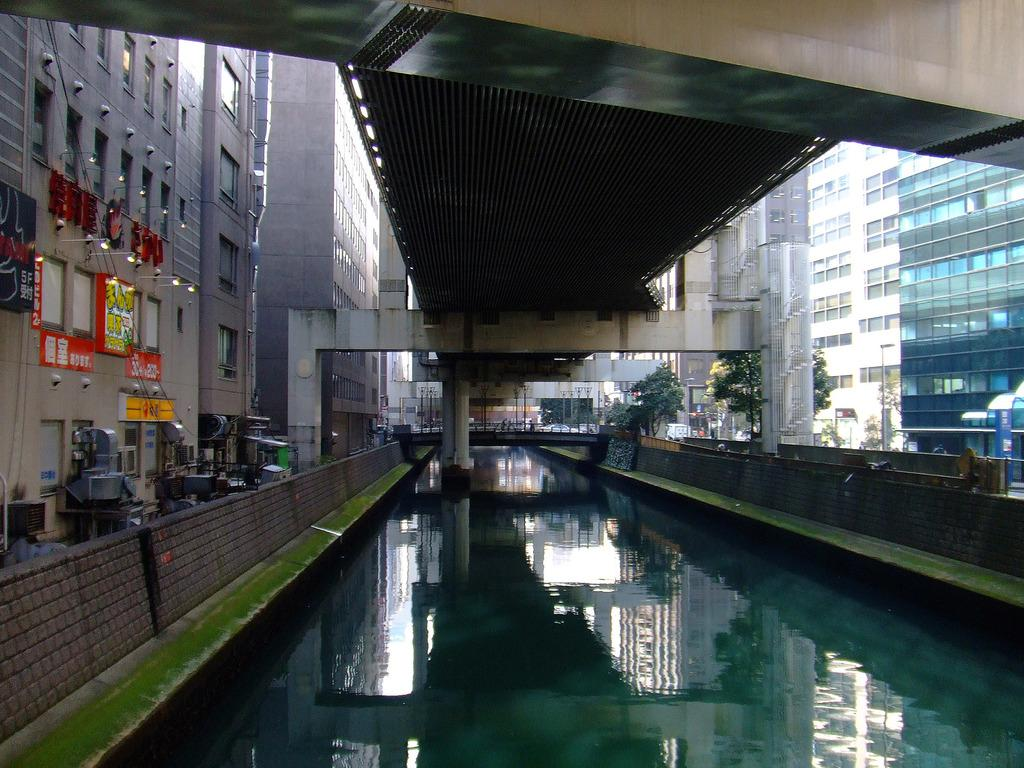What type of structures can be seen in the image? There are buildings in the image. What feature do the buildings have? The buildings have windows. What architectural element is present in the image? There is a bridge in the image. What supports the bridge or buildings in the image? There are pillars in the image. What type of signage is visible in the image? There are posters in the image. What can be seen illuminating the scene in the image? Lights are visible in the image. What type of vegetation is present in the image? Trees are present in the image. What natural element is visible in the image? There is water visible in the image. What type of music can be heard coming from the pigs in the image? There are no pigs present in the image, so it is not possible to determine what, if any, music might be heard. 